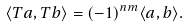<formula> <loc_0><loc_0><loc_500><loc_500>\langle T a , T b \rangle = ( - 1 ) ^ { n m } \langle a , b \rangle .</formula> 